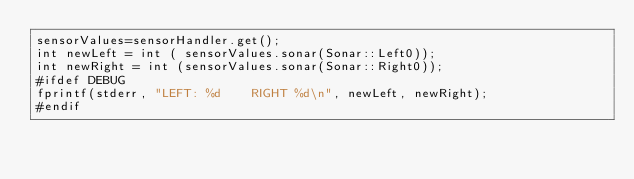Convert code to text. <code><loc_0><loc_0><loc_500><loc_500><_ObjectiveC_>sensorValues=sensorHandler.get();
int newLeft = int ( sensorValues.sonar(Sonar::Left0));
int newRight = int (sensorValues.sonar(Sonar::Right0));
#ifdef DEBUG
fprintf(stderr, "LEFT: %d    RIGHT %d\n", newLeft, newRight);
#endif
</code> 